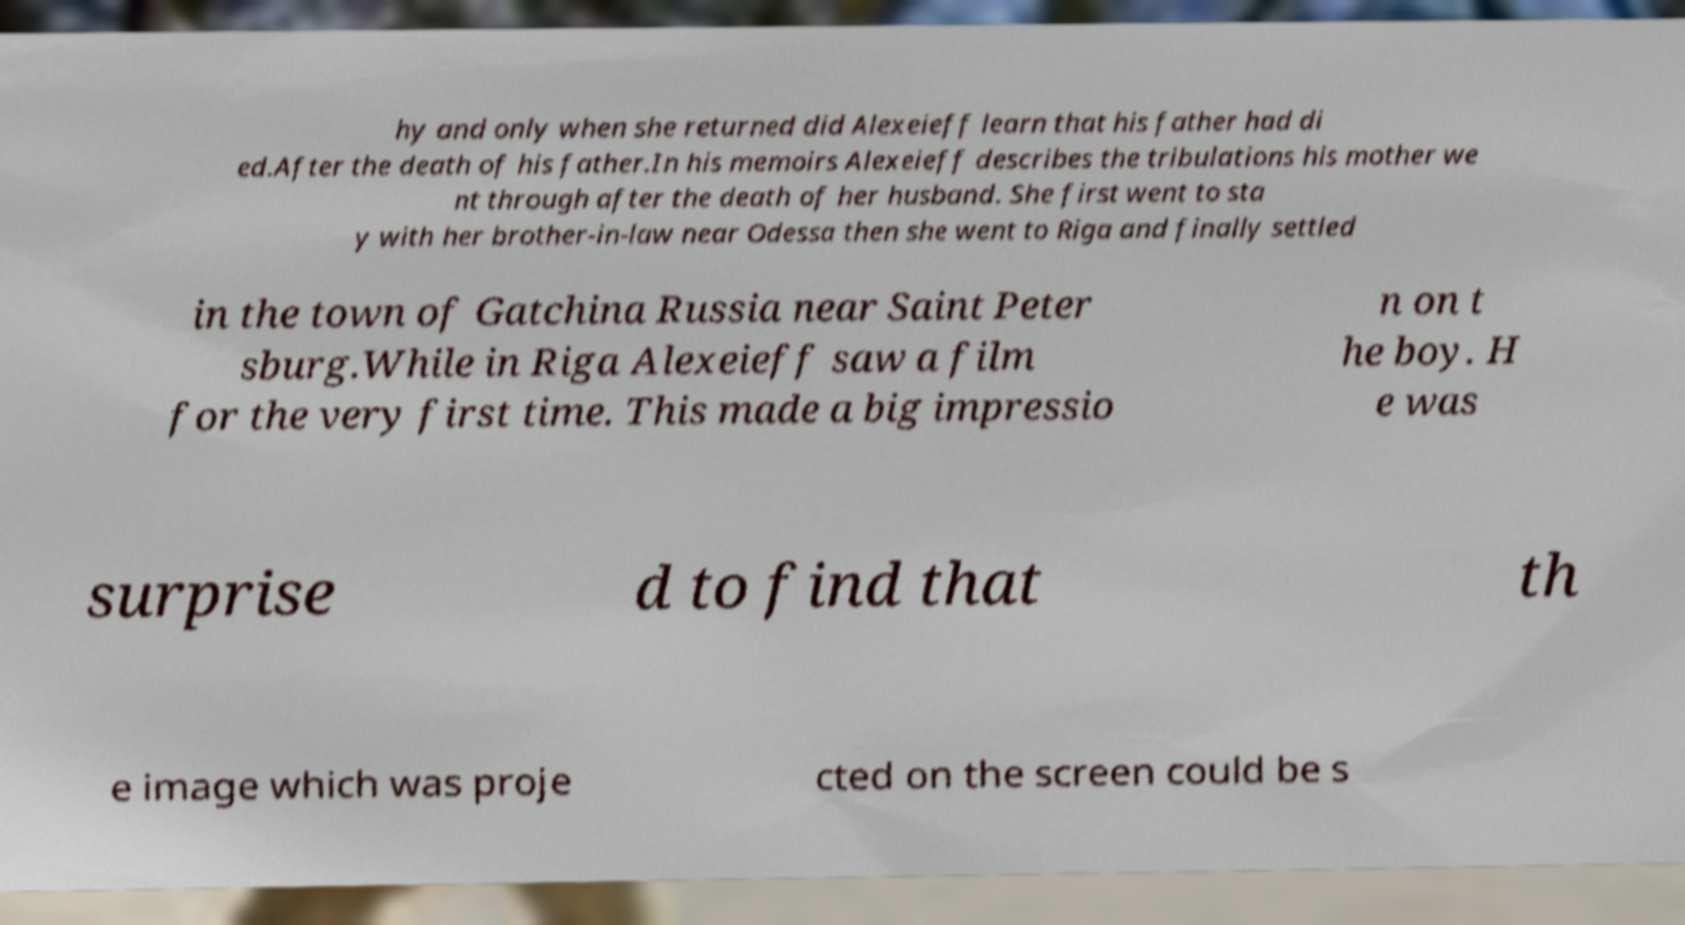I need the written content from this picture converted into text. Can you do that? hy and only when she returned did Alexeieff learn that his father had di ed.After the death of his father.In his memoirs Alexeieff describes the tribulations his mother we nt through after the death of her husband. She first went to sta y with her brother-in-law near Odessa then she went to Riga and finally settled in the town of Gatchina Russia near Saint Peter sburg.While in Riga Alexeieff saw a film for the very first time. This made a big impressio n on t he boy. H e was surprise d to find that th e image which was proje cted on the screen could be s 